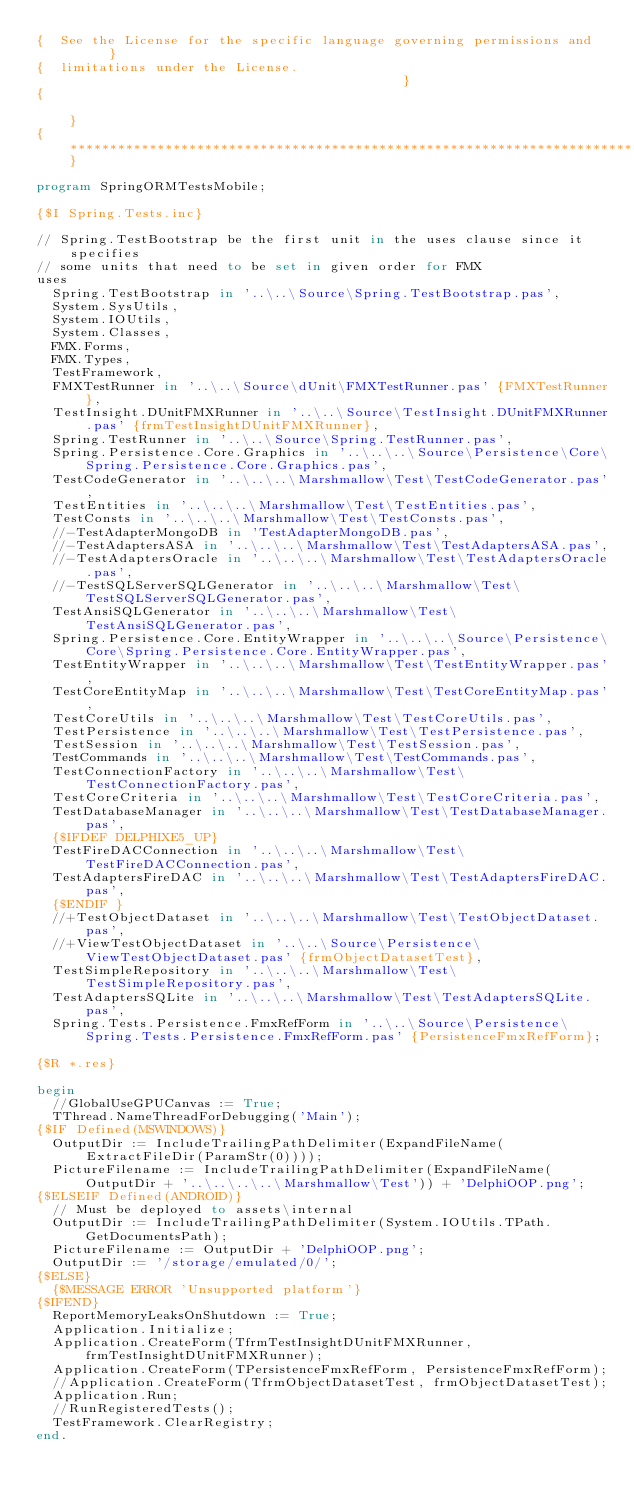Convert code to text. <code><loc_0><loc_0><loc_500><loc_500><_Pascal_>{  See the License for the specific language governing permissions and      }
{  limitations under the License.                                           }
{                                                                           }
{***************************************************************************}

program SpringORMTestsMobile;

{$I Spring.Tests.inc}

// Spring.TestBootstrap be the first unit in the uses clause since it specifies
// some units that need to be set in given order for FMX
uses
  Spring.TestBootstrap in '..\..\Source\Spring.TestBootstrap.pas',
  System.SysUtils,
  System.IOUtils,
  System.Classes,
  FMX.Forms,
  FMX.Types,
  TestFramework,
  FMXTestRunner in '..\..\Source\dUnit\FMXTestRunner.pas' {FMXTestRunner},
  TestInsight.DUnitFMXRunner in '..\..\Source\TestInsight.DUnitFMXRunner.pas' {frmTestInsightDUnitFMXRunner},
  Spring.TestRunner in '..\..\Source\Spring.TestRunner.pas',
  Spring.Persistence.Core.Graphics in '..\..\..\Source\Persistence\Core\Spring.Persistence.Core.Graphics.pas',
  TestCodeGenerator in '..\..\..\Marshmallow\Test\TestCodeGenerator.pas',
  TestEntities in '..\..\..\Marshmallow\Test\TestEntities.pas',
  TestConsts in '..\..\..\Marshmallow\Test\TestConsts.pas',
  //-TestAdapterMongoDB in 'TestAdapterMongoDB.pas',
  //-TestAdaptersASA in '..\..\..\Marshmallow\Test\TestAdaptersASA.pas',
  //-TestAdaptersOracle in '..\..\..\Marshmallow\Test\TestAdaptersOracle.pas',
  //-TestSQLServerSQLGenerator in '..\..\..\Marshmallow\Test\TestSQLServerSQLGenerator.pas',
  TestAnsiSQLGenerator in '..\..\..\Marshmallow\Test\TestAnsiSQLGenerator.pas',
  Spring.Persistence.Core.EntityWrapper in '..\..\..\Source\Persistence\Core\Spring.Persistence.Core.EntityWrapper.pas',
  TestEntityWrapper in '..\..\..\Marshmallow\Test\TestEntityWrapper.pas',
  TestCoreEntityMap in '..\..\..\Marshmallow\Test\TestCoreEntityMap.pas',
  TestCoreUtils in '..\..\..\Marshmallow\Test\TestCoreUtils.pas',
  TestPersistence in '..\..\..\Marshmallow\Test\TestPersistence.pas',
  TestSession in '..\..\..\Marshmallow\Test\TestSession.pas',
  TestCommands in '..\..\..\Marshmallow\Test\TestCommands.pas',
  TestConnectionFactory in '..\..\..\Marshmallow\Test\TestConnectionFactory.pas',
  TestCoreCriteria in '..\..\..\Marshmallow\Test\TestCoreCriteria.pas',
  TestDatabaseManager in '..\..\..\Marshmallow\Test\TestDatabaseManager.pas',
  {$IFDEF DELPHIXE5_UP}
  TestFireDACConnection in '..\..\..\Marshmallow\Test\TestFireDACConnection.pas',
  TestAdaptersFireDAC in '..\..\..\Marshmallow\Test\TestAdaptersFireDAC.pas',
  {$ENDIF }
  //+TestObjectDataset in '..\..\..\Marshmallow\Test\TestObjectDataset.pas',
  //+ViewTestObjectDataset in '..\..\Source\Persistence\ViewTestObjectDataset.pas' {frmObjectDatasetTest},
  TestSimpleRepository in '..\..\..\Marshmallow\Test\TestSimpleRepository.pas',
  TestAdaptersSQLite in '..\..\..\Marshmallow\Test\TestAdaptersSQLite.pas',
  Spring.Tests.Persistence.FmxRefForm in '..\..\Source\Persistence\Spring.Tests.Persistence.FmxRefForm.pas' {PersistenceFmxRefForm};

{$R *.res}

begin
  //GlobalUseGPUCanvas := True;
  TThread.NameThreadForDebugging('Main');
{$IF Defined(MSWINDOWS)}
  OutputDir := IncludeTrailingPathDelimiter(ExpandFileName(ExtractFileDir(ParamStr(0))));
  PictureFilename := IncludeTrailingPathDelimiter(ExpandFileName(OutputDir + '..\..\..\..\Marshmallow\Test')) + 'DelphiOOP.png';
{$ELSEIF Defined(ANDROID)}
  // Must be deployed to assets\internal
  OutputDir := IncludeTrailingPathDelimiter(System.IOUtils.TPath.GetDocumentsPath);
  PictureFilename := OutputDir + 'DelphiOOP.png';
  OutputDir := '/storage/emulated/0/';
{$ELSE}
  {$MESSAGE ERROR 'Unsupported platform'}
{$IFEND}
  ReportMemoryLeaksOnShutdown := True;
  Application.Initialize;
  Application.CreateForm(TfrmTestInsightDUnitFMXRunner, frmTestInsightDUnitFMXRunner);
  Application.CreateForm(TPersistenceFmxRefForm, PersistenceFmxRefForm);
  //Application.CreateForm(TfrmObjectDatasetTest, frmObjectDatasetTest);
  Application.Run;
  //RunRegisteredTests();
  TestFramework.ClearRegistry;
end.
</code> 